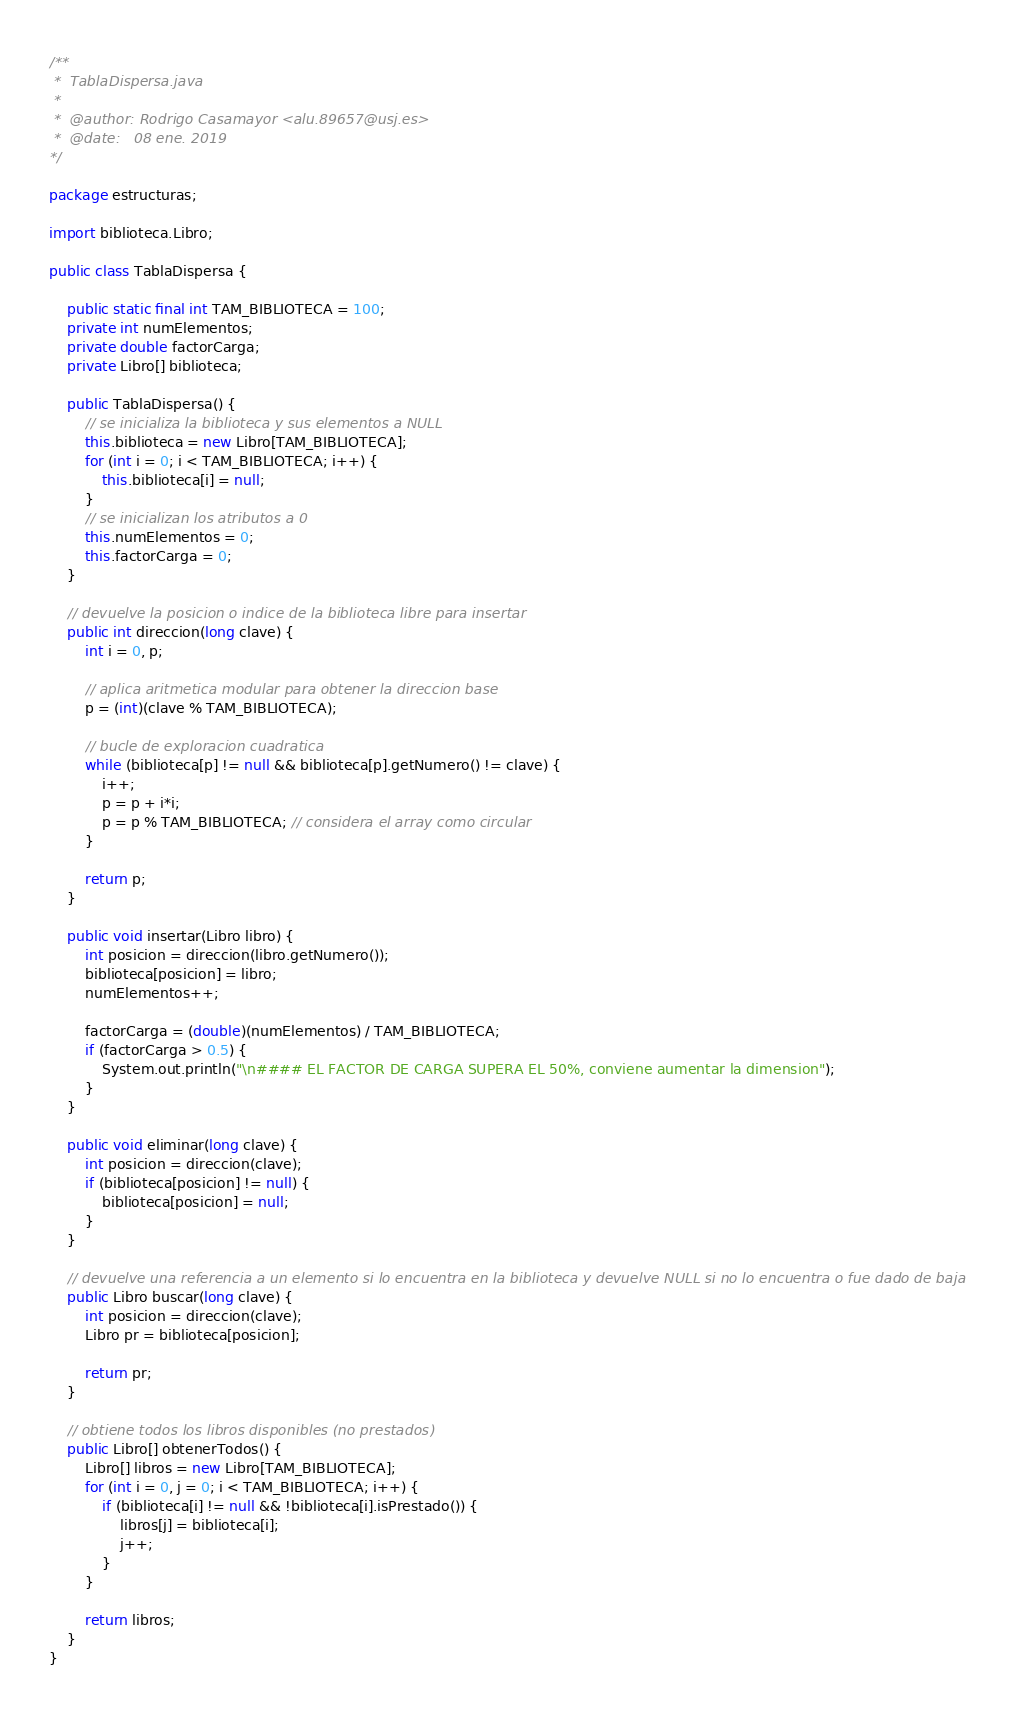Convert code to text. <code><loc_0><loc_0><loc_500><loc_500><_Java_>/**
 *  TablaDispersa.java
 *
 *  @author: Rodrigo Casamayor <alu.89657@usj.es>
 *  @date:   08 ene. 2019
*/

package estructuras;

import biblioteca.Libro;

public class TablaDispersa {

	public static final int TAM_BIBLIOTECA = 100;
	private int numElementos;
	private double factorCarga;
	private Libro[] biblioteca;

	public TablaDispersa() {
		// se inicializa la biblioteca y sus elementos a NULL
		this.biblioteca = new Libro[TAM_BIBLIOTECA];
		for (int i = 0; i < TAM_BIBLIOTECA; i++) {
			this.biblioteca[i] = null;
		}
		// se inicializan los atributos a 0
		this.numElementos = 0;
		this.factorCarga = 0;
	}

	// devuelve la posicion o indice de la biblioteca libre para insertar
	public int direccion(long clave) {
		int i = 0, p;

		// aplica aritmetica modular para obtener la direccion base
		p = (int)(clave % TAM_BIBLIOTECA);

		// bucle de exploracion cuadratica
		while (biblioteca[p] != null && biblioteca[p].getNumero() != clave) {
			i++;
			p = p + i*i;
			p = p % TAM_BIBLIOTECA; // considera el array como circular
		}

		return p;
	}

	public void insertar(Libro libro) {
		int posicion = direccion(libro.getNumero());
		biblioteca[posicion] = libro;
		numElementos++;

		factorCarga = (double)(numElementos) / TAM_BIBLIOTECA;
		if (factorCarga > 0.5) {
			System.out.println("\n#### EL FACTOR DE CARGA SUPERA EL 50%, conviene aumentar la dimension");
		}
	}

	public void eliminar(long clave) {
		int posicion = direccion(clave);
		if (biblioteca[posicion] != null) {
			biblioteca[posicion] = null;
		}
	}

	// devuelve una referencia a un elemento si lo encuentra en la biblioteca y devuelve NULL si no lo encuentra o fue dado de baja
	public Libro buscar(long clave) {
		int posicion = direccion(clave);
		Libro pr = biblioteca[posicion];

		return pr;
	}

	// obtiene todos los libros disponibles (no prestados)
	public Libro[] obtenerTodos() {
		Libro[] libros = new Libro[TAM_BIBLIOTECA];
		for (int i = 0, j = 0; i < TAM_BIBLIOTECA; i++) {
			if (biblioteca[i] != null && !biblioteca[i].isPrestado()) {
				libros[j] = biblioteca[i];
				j++;
			}
		}

		return libros;
	}
}
</code> 